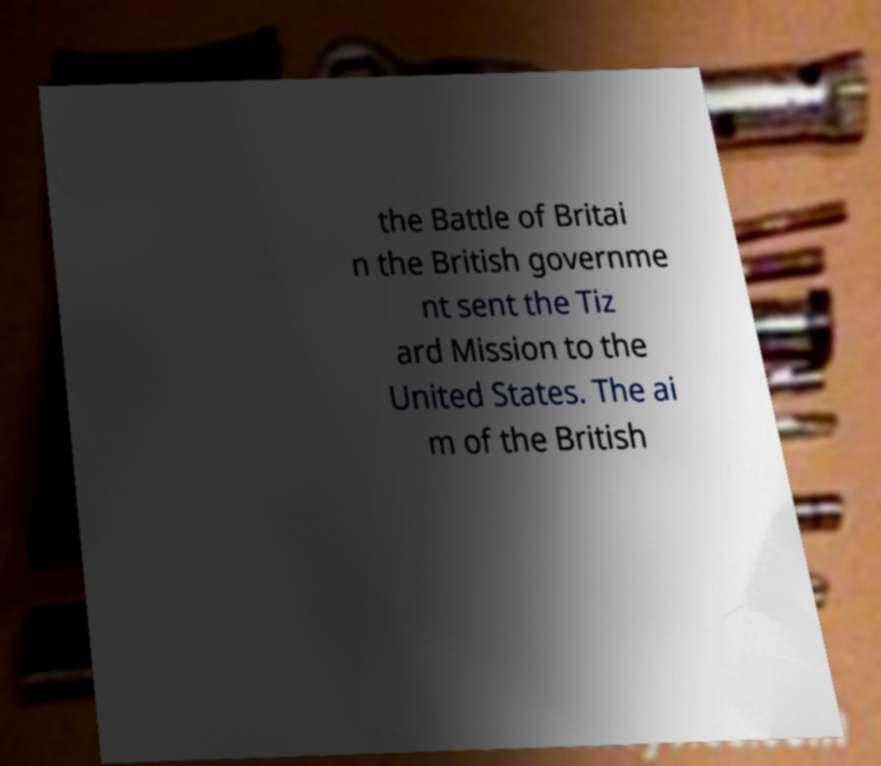Please identify and transcribe the text found in this image. the Battle of Britai n the British governme nt sent the Tiz ard Mission to the United States. The ai m of the British 